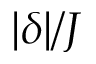Convert formula to latex. <formula><loc_0><loc_0><loc_500><loc_500>| \delta | / J</formula> 